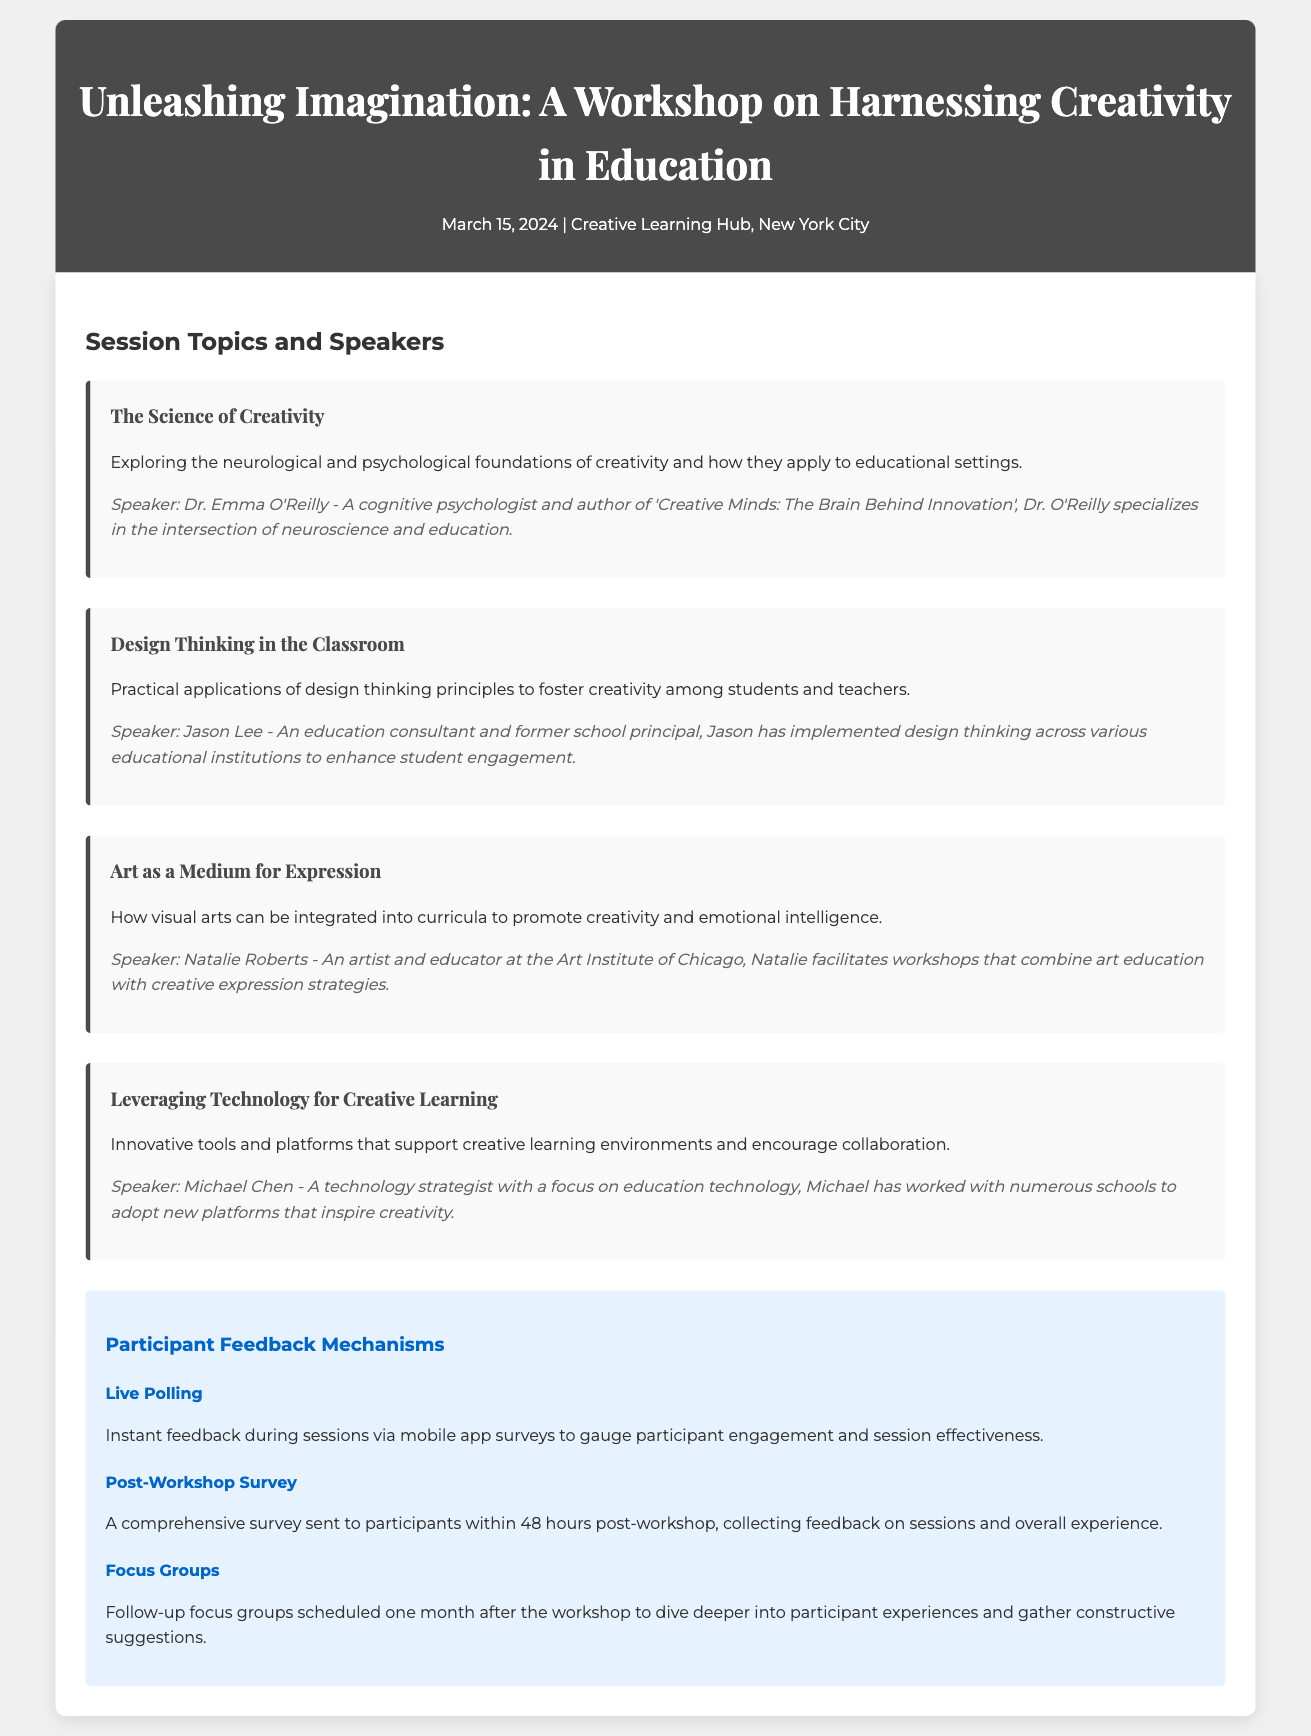What is the title of the workshop? The title is explicitly stated at the top of the memo, which is to engage the reader’s imagination.
Answer: Unleashing Imagination: A Workshop on Harnessing Creativity in Education Who is the speaker for the session on Design Thinking in the Classroom? This information can be found in the session details provided in the document, specifically related to the Design Thinking topic.
Answer: Jason Lee What date is the workshop scheduled for? The date is mentioned in the header section of the memo, providing essential timing information.
Answer: March 15, 2024 How many feedback mechanisms are mentioned in the document? The document lists three distinct feedback mechanisms, which are organized under a feedback section.
Answer: Three What is the focus of the session titled Leveraging Technology for Creative Learning? This session discusses the use of innovative tools to enhance the educational experience, which is derived from the session description.
Answer: Innovative tools and platforms What comprehensive survey activity is planned post-workshop? This detail is specified within the feedback mechanisms section, outlining how participant experiences will be collected after the workshop.
Answer: Post-Workshop Survey What art institution is Natalie Roberts associated with? The document mentions her role and affiliation, directly connected to her speaker information.
Answer: Art Institute of Chicago What type of feedback is gathered immediately during the sessions? This type of feedback is specified under the participant feedback mechanisms, indicating an active engagement measure.
Answer: Live Polling 